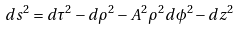<formula> <loc_0><loc_0><loc_500><loc_500>d s ^ { 2 } = d \tau ^ { 2 } - d \rho ^ { 2 } - A ^ { 2 } \rho ^ { 2 } d \phi ^ { 2 } - d z ^ { 2 }</formula> 